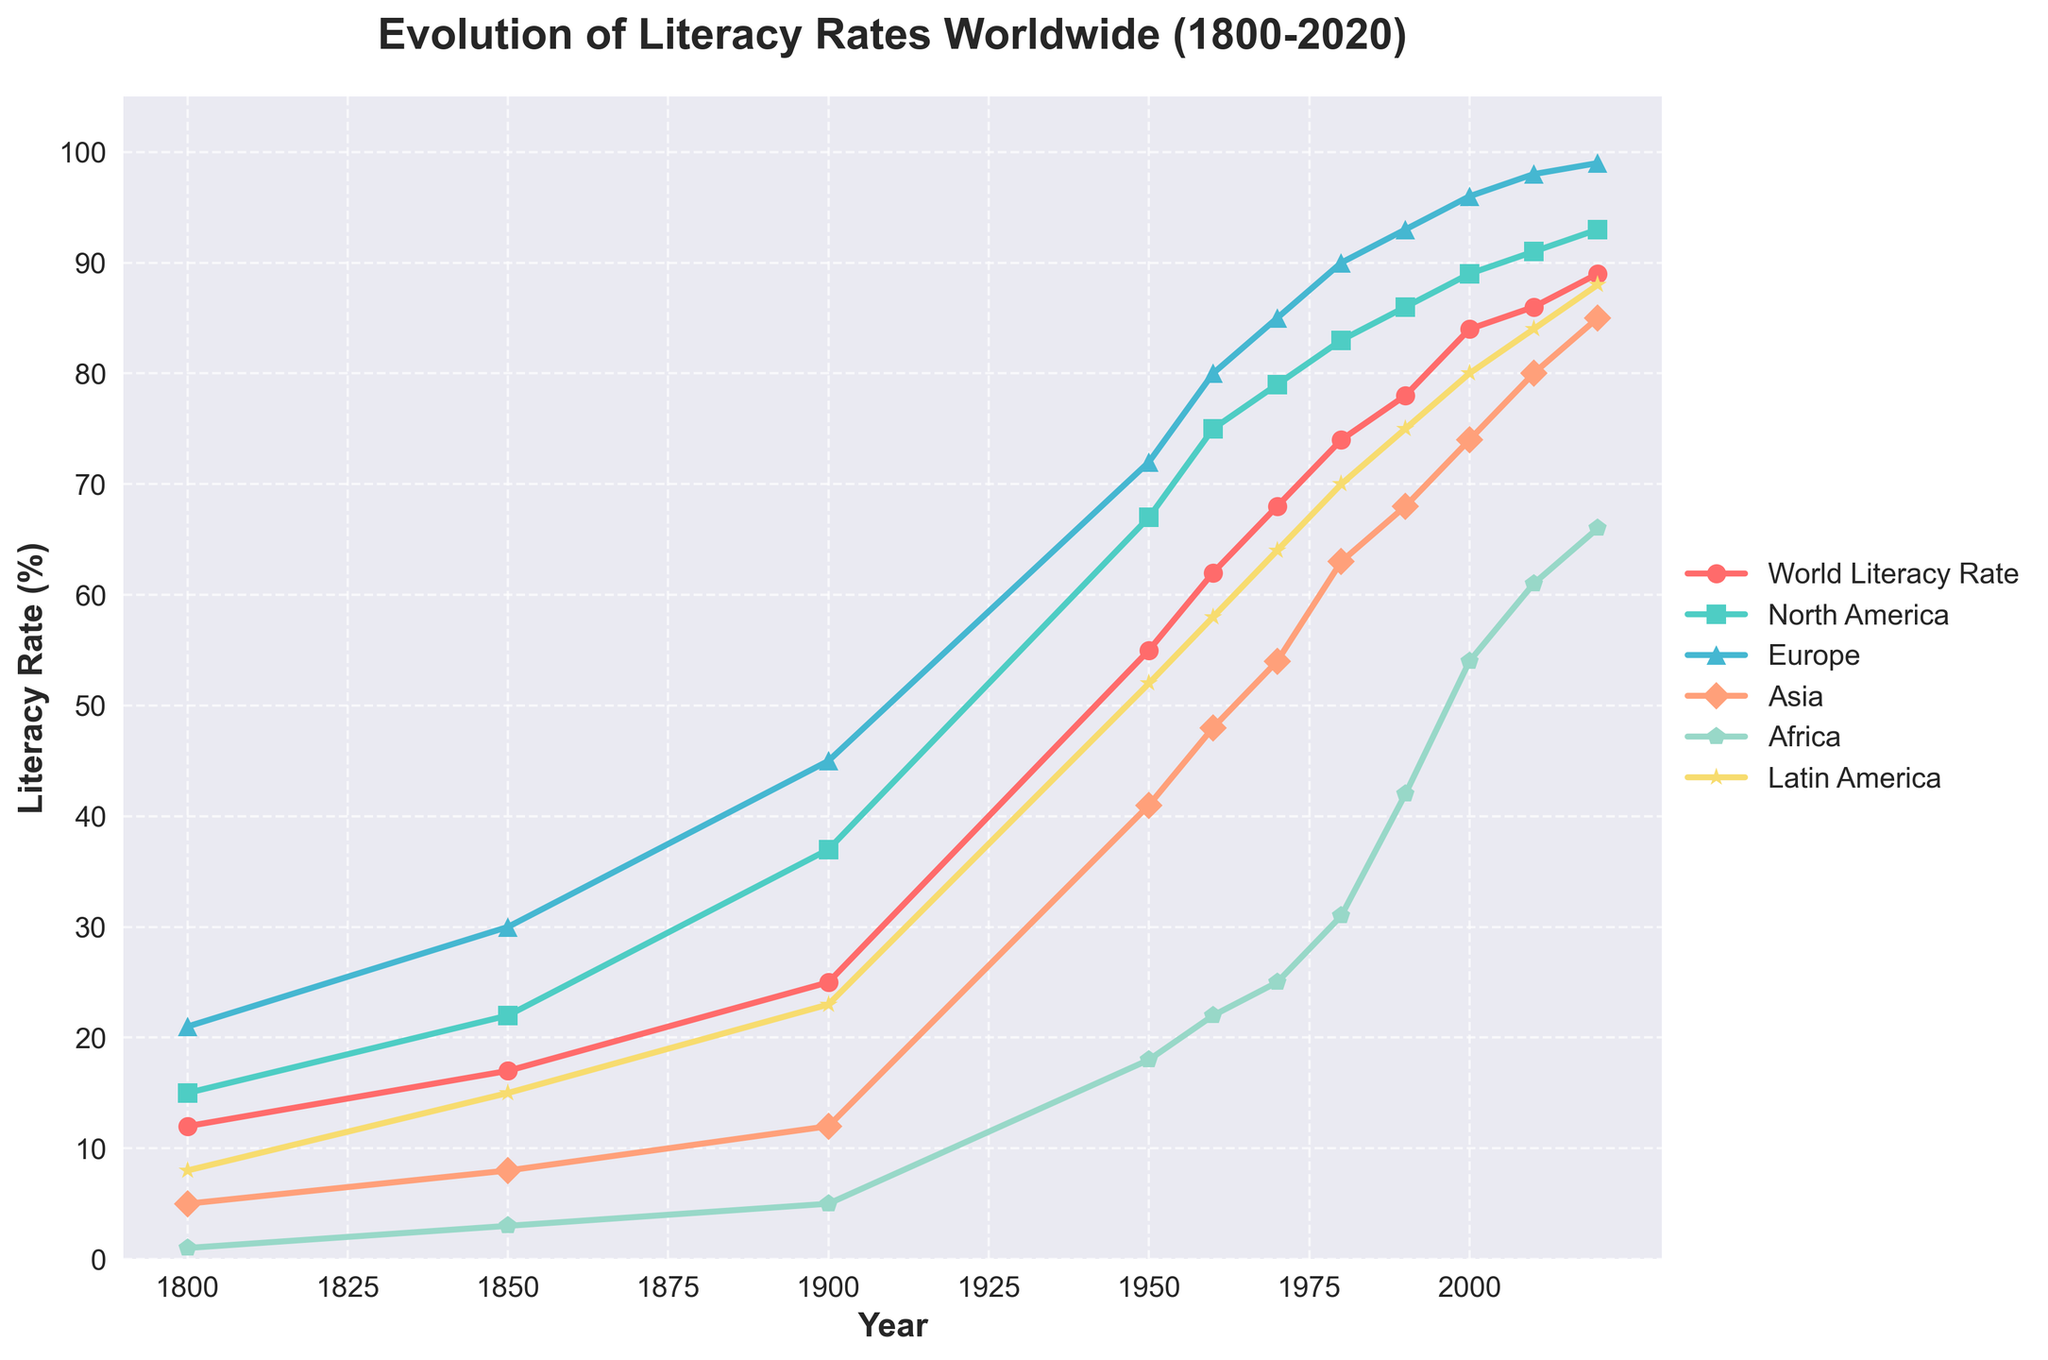What is the title of the plot? The title of the plot can be seen at the top center of the figure, which describes what the plot is about.
Answer: Evolution of Literacy Rates Worldwide (1800-2020) What is the literacy rate for Africa in 1950? Find the point on the graph corresponding to the year 1950 and look at the y-value for the line representing Africa.
Answer: 18% Which region had the highest literacy rate in 1900? By inspecting the plot, identify the line with the highest y-value at the year 1900.
Answer: Europe How did the literacy rate in Asia change from 1950 to 2020? Locate the points on the plot for Asia at the years 1950 and 2020, then compare their y-values.
Answer: Increased from 41% to 85% What is the difference in literacy rates between North America and Africa in 2000? Find the y-values for North America and Africa at the year 2000, then subtract the value for Africa from that of North America.
Answer: 35% Which two regions have shown the most similar trends in literacy rate changes over time? Look at the overall trajectory of the lines for each region and identify which two lines follow a similar pattern throughout the time period.
Answer: North America and Europe What is the approximate average increase in literacy rate worldwide every 50 years? Find the literacy rates for the world at each 50-year interval (1800, 1850, 1900, 1950, 2000), calculate the differences between each successive interval, and take their average.
Answer: Approximately 19.25% Which year showed the highest overall increase in literacy rates globally? Identify the largest upward slope on the World Literacy Rate line by examining the steepest increase between any two consecutive data points.
Answer: 1900 to 1950 How does the literacy rate in Latin America in 2020 compare to Europe in 1950? Look at the y-values for Latin America in 2020 and Europe in 1950 and compare them.
Answer: Latin America in 2020 is higher (88% vs. 72%) What is the growth rate of literacy in Africa from 1900 to 2000? Find the literacy rates for Africa in 1900 and 2000, subtract the value for 1900 from the value for 2000, and divide by the number of years (2000-1900).
Answer: (54% - 5%) / 100 = 0.49% per year 